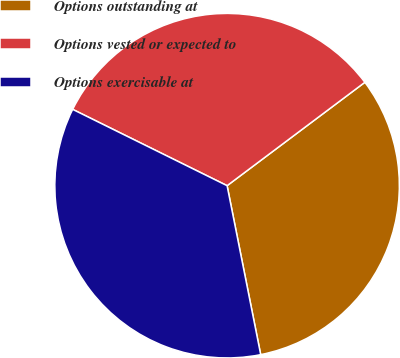Convert chart to OTSL. <chart><loc_0><loc_0><loc_500><loc_500><pie_chart><fcel>Options outstanding at<fcel>Options vested or expected to<fcel>Options exercisable at<nl><fcel>32.12%<fcel>32.45%<fcel>35.43%<nl></chart> 